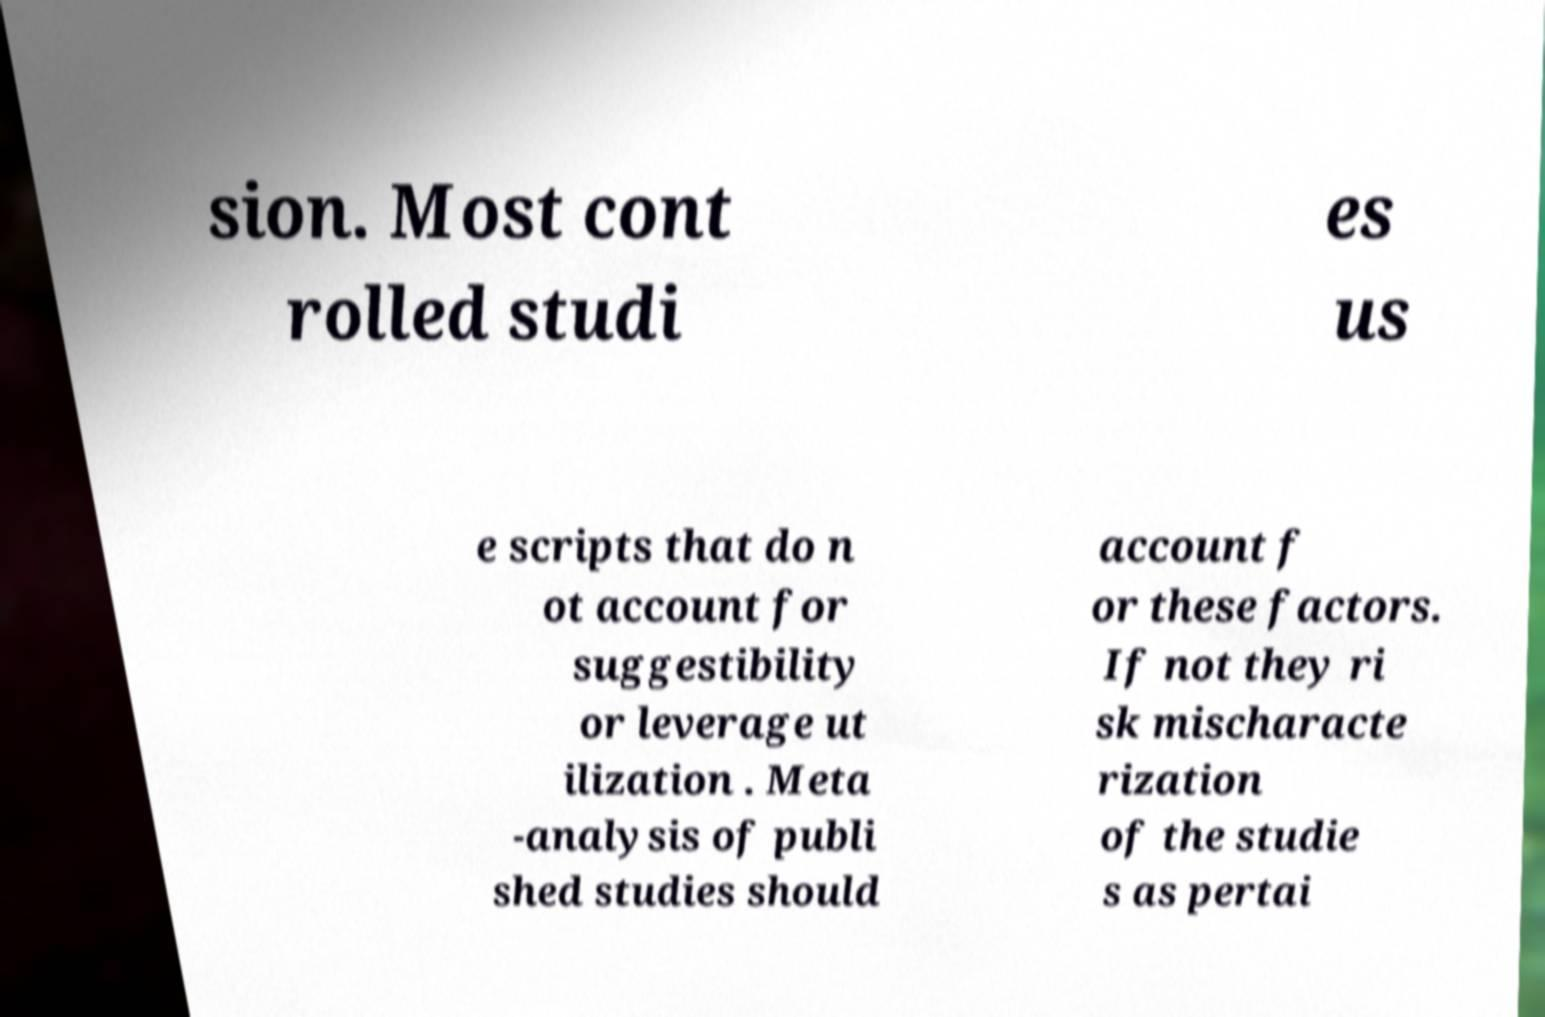Can you read and provide the text displayed in the image?This photo seems to have some interesting text. Can you extract and type it out for me? sion. Most cont rolled studi es us e scripts that do n ot account for suggestibility or leverage ut ilization . Meta -analysis of publi shed studies should account f or these factors. If not they ri sk mischaracte rization of the studie s as pertai 